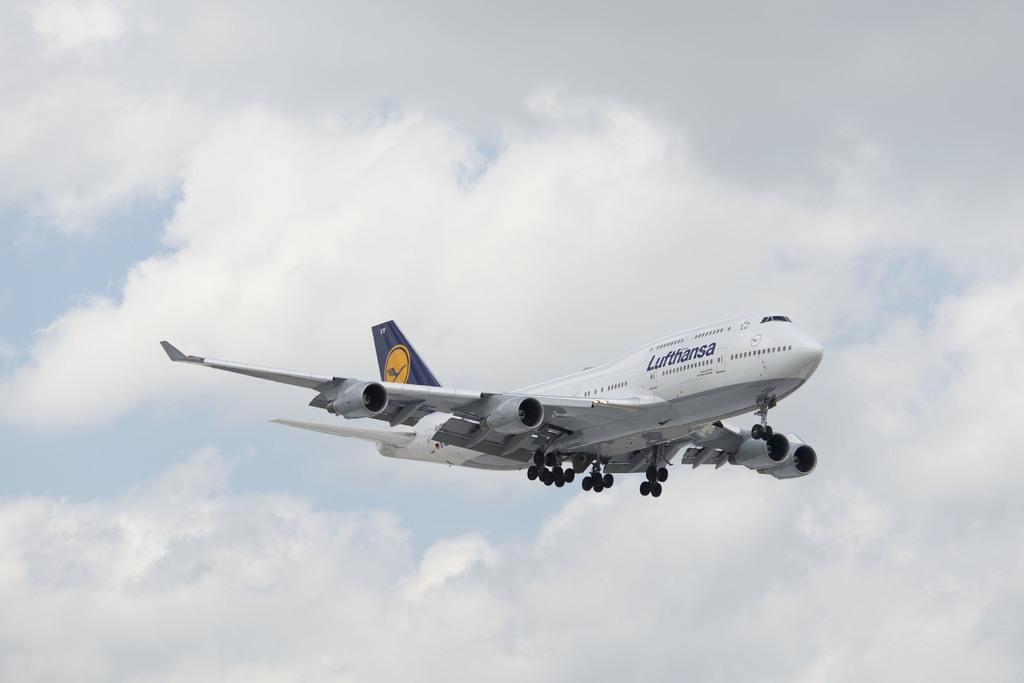Please provide a concise description of this image. In this image we can see an airplane in the air. Behind the airline, we can see the clear sky. 